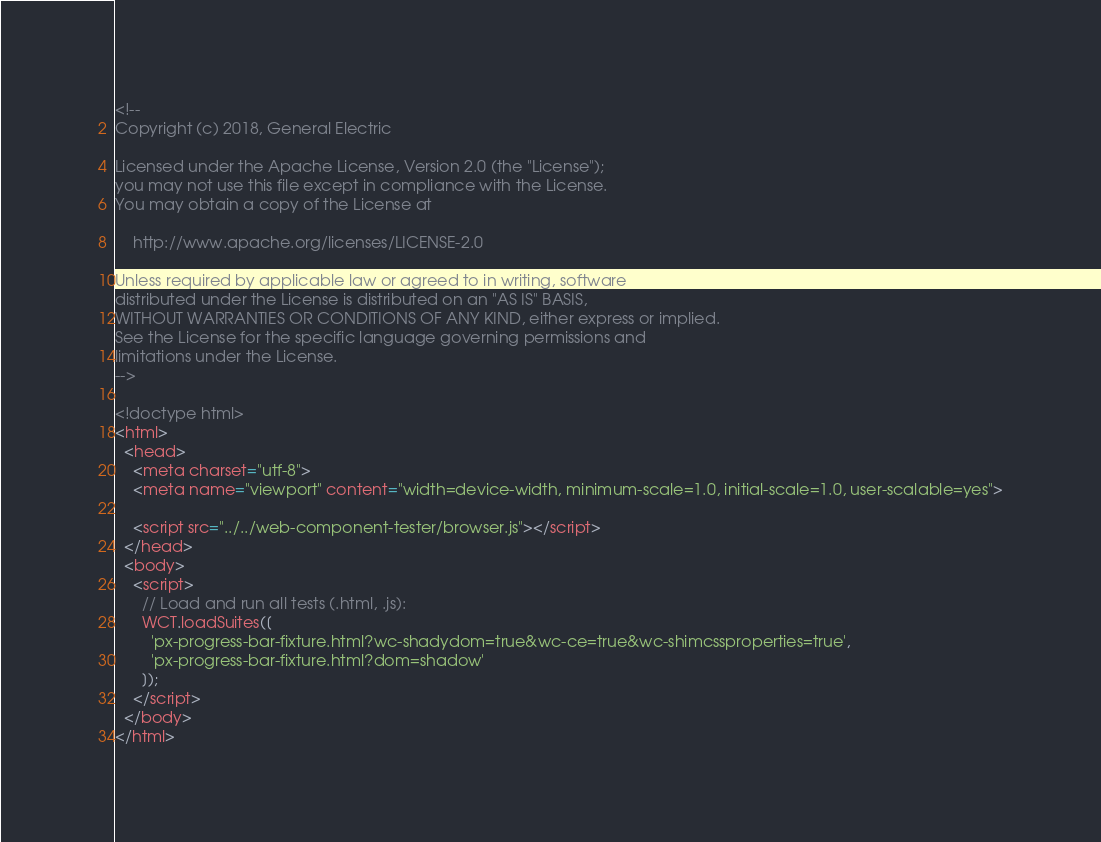Convert code to text. <code><loc_0><loc_0><loc_500><loc_500><_HTML_><!--
Copyright (c) 2018, General Electric

Licensed under the Apache License, Version 2.0 (the "License");
you may not use this file except in compliance with the License.
You may obtain a copy of the License at

    http://www.apache.org/licenses/LICENSE-2.0

Unless required by applicable law or agreed to in writing, software
distributed under the License is distributed on an "AS IS" BASIS,
WITHOUT WARRANTIES OR CONDITIONS OF ANY KIND, either express or implied.
See the License for the specific language governing permissions and
limitations under the License.
-->

<!doctype html>
<html>
  <head>
    <meta charset="utf-8">
    <meta name="viewport" content="width=device-width, minimum-scale=1.0, initial-scale=1.0, user-scalable=yes">

    <script src="../../web-component-tester/browser.js"></script>
  </head>
  <body>
    <script>
      // Load and run all tests (.html, .js):
      WCT.loadSuites([
        'px-progress-bar-fixture.html?wc-shadydom=true&wc-ce=true&wc-shimcssproperties=true',
        'px-progress-bar-fixture.html?dom=shadow'
      ]);
    </script>
  </body>
</html>
</code> 